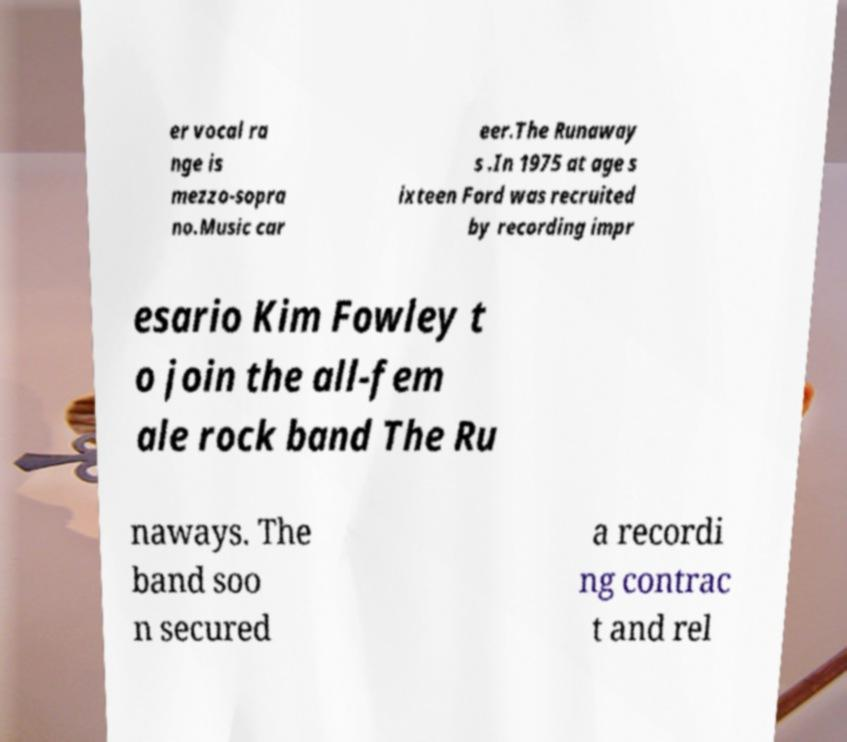There's text embedded in this image that I need extracted. Can you transcribe it verbatim? er vocal ra nge is mezzo-sopra no.Music car eer.The Runaway s .In 1975 at age s ixteen Ford was recruited by recording impr esario Kim Fowley t o join the all-fem ale rock band The Ru naways. The band soo n secured a recordi ng contrac t and rel 